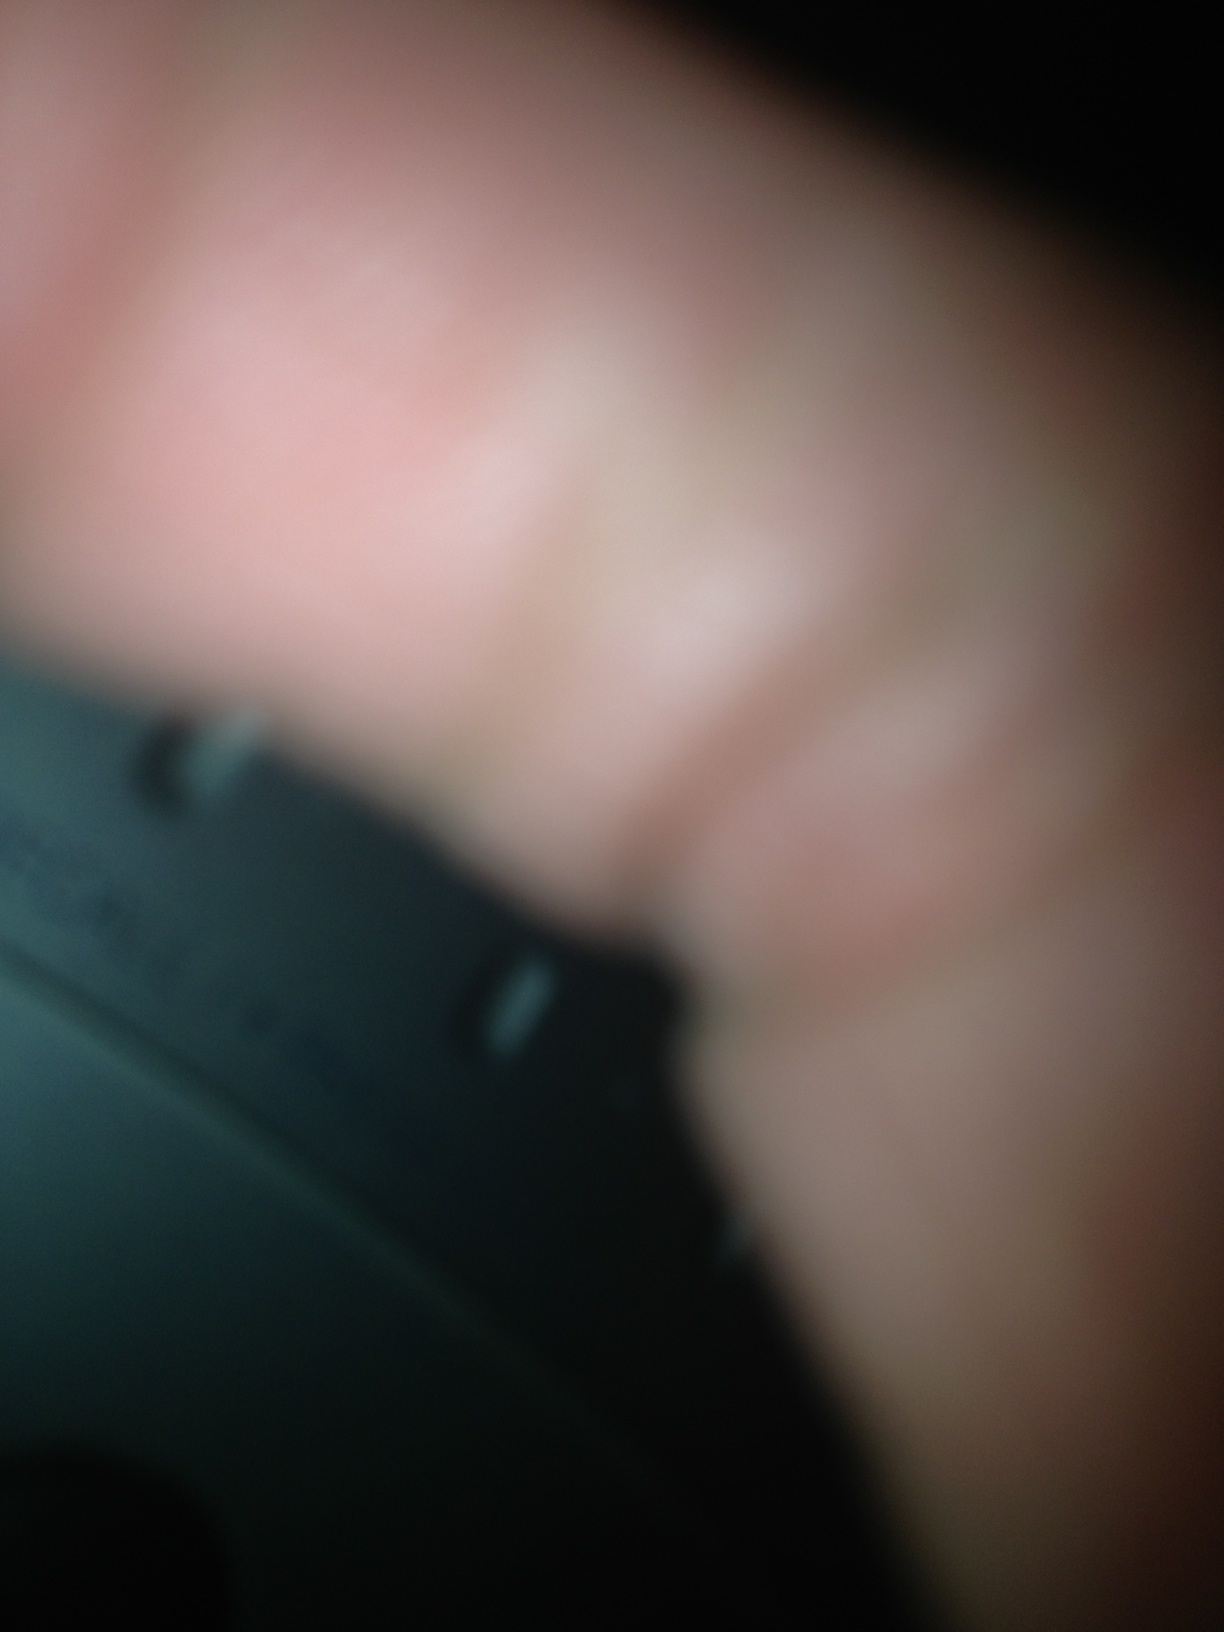Can you describe the object in the image? The image shows a very blurry close-up of what appears to be a finger partially covering a black, circular object. The black object might have some markings or indents, but it is difficult to identify due to the blurriness. What do you think the markings on the black object could indicate? The markings on the black object could potentially indicate various things, such as volume levels, settings, or other identifiers. It might be part of a dial or a control panel, possibly for an electronic device like a radio, but this remains speculative given the clarity of the image. 